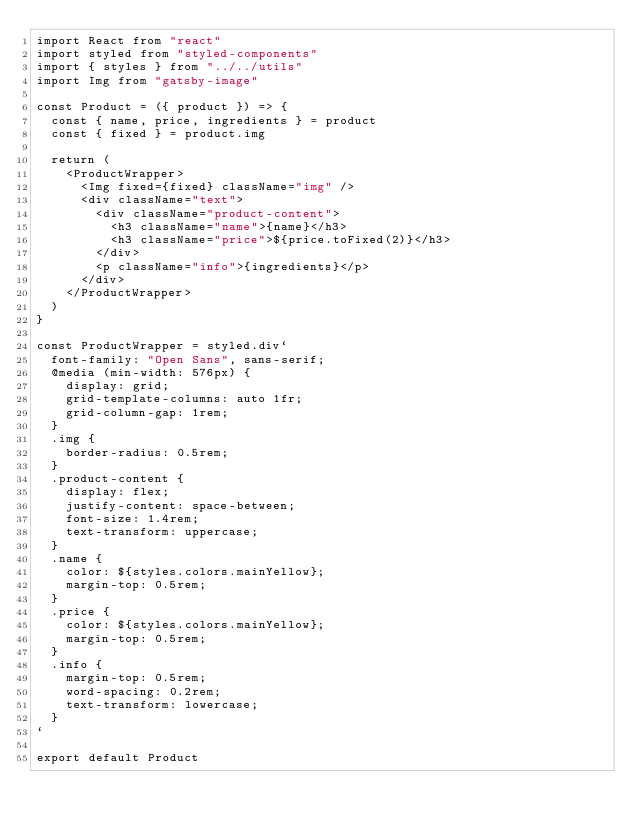<code> <loc_0><loc_0><loc_500><loc_500><_JavaScript_>import React from "react"
import styled from "styled-components"
import { styles } from "../../utils"
import Img from "gatsby-image"

const Product = ({ product }) => {
  const { name, price, ingredients } = product
  const { fixed } = product.img

  return (
    <ProductWrapper>
      <Img fixed={fixed} className="img" />
      <div className="text">
        <div className="product-content">
          <h3 className="name">{name}</h3>
          <h3 className="price">${price.toFixed(2)}</h3>
        </div>
        <p className="info">{ingredients}</p>
      </div>
    </ProductWrapper>
  )
}

const ProductWrapper = styled.div`
  font-family: "Open Sans", sans-serif;
  @media (min-width: 576px) {
    display: grid;
    grid-template-columns: auto 1fr;
    grid-column-gap: 1rem;
  }
  .img {
    border-radius: 0.5rem;
  }
  .product-content {
    display: flex;
    justify-content: space-between;
    font-size: 1.4rem;
    text-transform: uppercase;
  }
  .name {
    color: ${styles.colors.mainYellow};
    margin-top: 0.5rem;
  }
  .price {
    color: ${styles.colors.mainYellow};
    margin-top: 0.5rem;
  }
  .info {
    margin-top: 0.5rem;
    word-spacing: 0.2rem;
    text-transform: lowercase;
  }
`

export default Product
</code> 